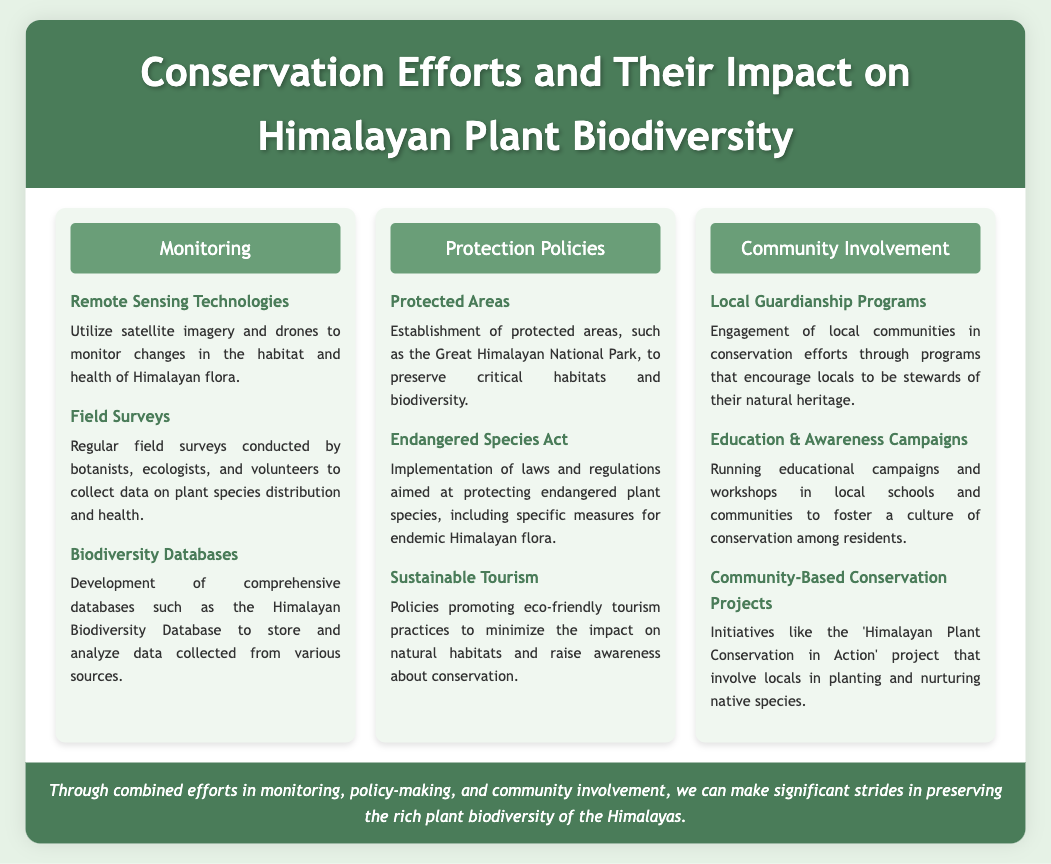What technologies are used for monitoring? The document lists remote sensing technologies, such as satellite imagery and drones, as means to monitor changes in habitat and health of Himalayan flora.
Answer: Remote Sensing Technologies What is a key conservation policy mentioned? The document highlights the establishment of protected areas as a key conservation policy to preserve habitats and biodiversity.
Answer: Protected Areas What initiative involves community participation in conservation? The 'Himalayan Plant Conservation in Action' project is an initiative that involves locals in planting and nurturing native species.
Answer: Himalayan Plant Conservation in Action What do education campaigns aim to foster? The document states that education and awareness campaigns aim to foster a culture of conservation among residents.
Answer: Culture of conservation How many sections are in the infographic? There are three sections in the infographic: Monitoring, Protection Policies, and Community Involvement.
Answer: Three What type of survey is conducted regularly? Regular field surveys are conducted by botanists, ecologists, and volunteers to collect data on plant species distribution and health.
Answer: Field Surveys What is the font used for the container's text? The document states that the font used for the container's text is 'Trebuchet MS'.
Answer: Trebuchet MS What is the color theme of the header? The header has a green color theme, specifically #4a7c59, which is indicated in the document.
Answer: #4a7c59 